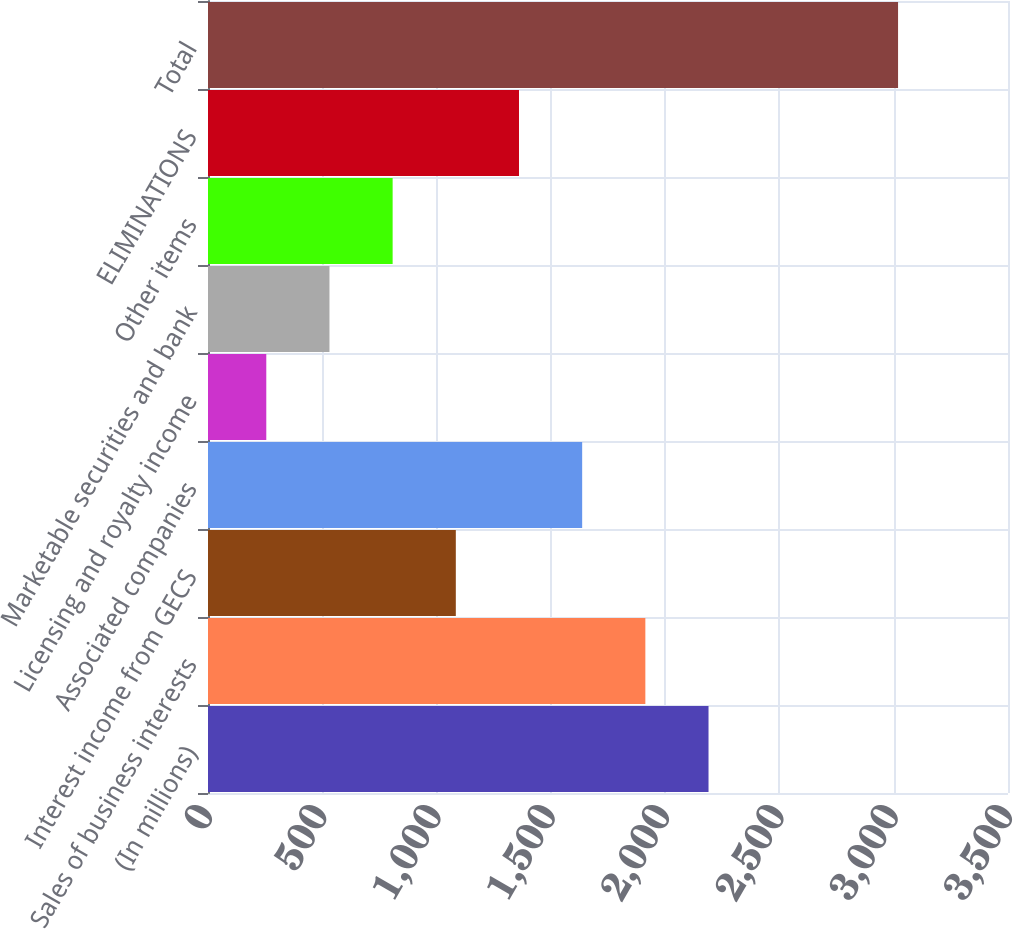Convert chart. <chart><loc_0><loc_0><loc_500><loc_500><bar_chart><fcel>(In millions)<fcel>Sales of business interests<fcel>Interest income from GECS<fcel>Associated companies<fcel>Licensing and royalty income<fcel>Marketable securities and bank<fcel>Other items<fcel>ELIMINATIONS<fcel>Total<nl><fcel>2189.8<fcel>1913.4<fcel>1084.2<fcel>1637<fcel>255<fcel>531.4<fcel>807.8<fcel>1360.6<fcel>3019<nl></chart> 